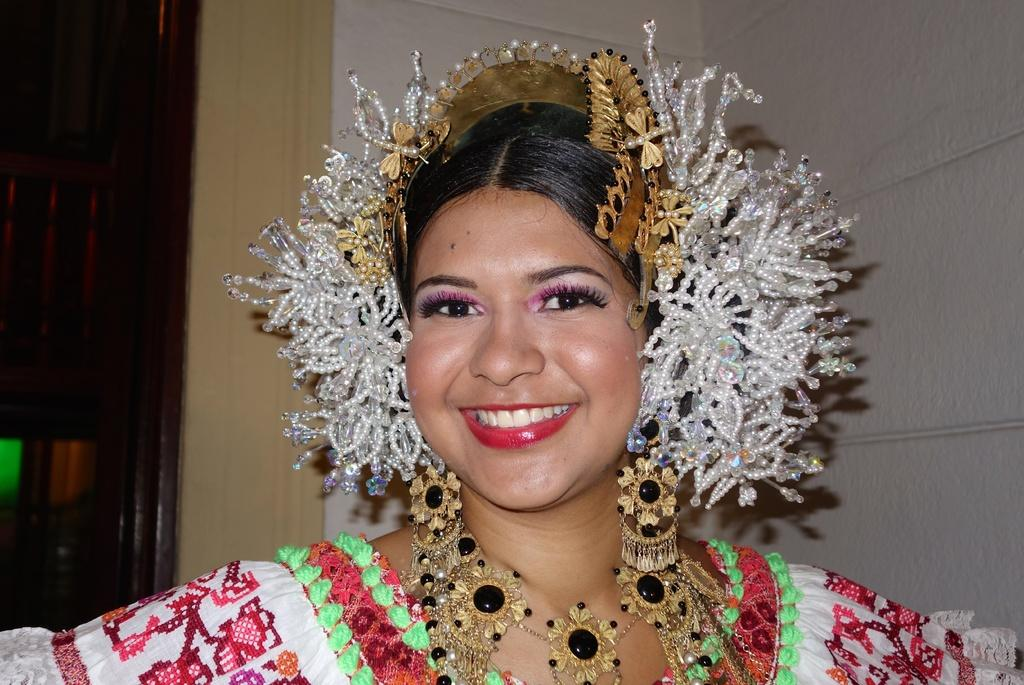Who is present in the image? There is a woman in the image. What is the woman's facial expression? The woman is smiling. What else can be observed about the woman's appearance? The woman is wearing accessories. What type of flame can be seen in the image? There is no flame present in the image. Does the woman in the image express any regret? There is no indication of regret in the woman's facial expression or body language in the image. 